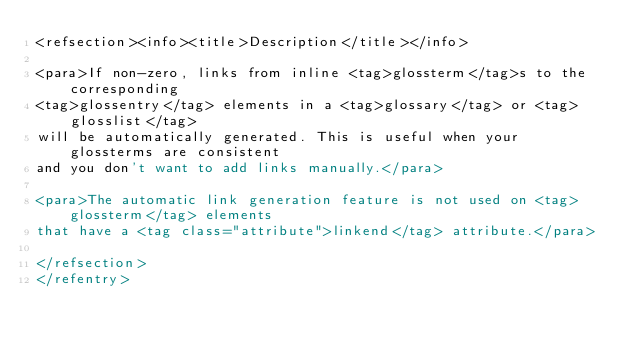Convert code to text. <code><loc_0><loc_0><loc_500><loc_500><_XML_><refsection><info><title>Description</title></info>

<para>If non-zero, links from inline <tag>glossterm</tag>s to the corresponding 
<tag>glossentry</tag> elements in a <tag>glossary</tag> or <tag>glosslist</tag> 
will be automatically generated. This is useful when your glossterms are consistent 
and you don't want to add links manually.</para>

<para>The automatic link generation feature is not used on <tag>glossterm</tag> elements
that have a <tag class="attribute">linkend</tag> attribute.</para>

</refsection>
</refentry>
</code> 